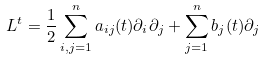<formula> <loc_0><loc_0><loc_500><loc_500>L ^ { t } = \frac { 1 } { 2 } \sum _ { i , j = 1 } ^ { n } a _ { i j } ( t ) \partial _ { i } \partial _ { j } + \sum _ { j = 1 } ^ { n } b _ { j } ( t ) \partial _ { j }</formula> 